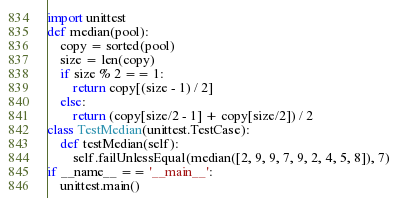Convert code to text. <code><loc_0><loc_0><loc_500><loc_500><_Python_>import unittest
def median(pool):
    copy = sorted(pool)
    size = len(copy)
    if size % 2 == 1:
        return copy[(size - 1) / 2]
    else:
        return (copy[size/2 - 1] + copy[size/2]) / 2
class TestMedian(unittest.TestCase):
    def testMedian(self):
        self.failUnlessEqual(median([2, 9, 9, 7, 9, 2, 4, 5, 8]), 7)
if __name__ == '__main__':
    unittest.main()
</code> 